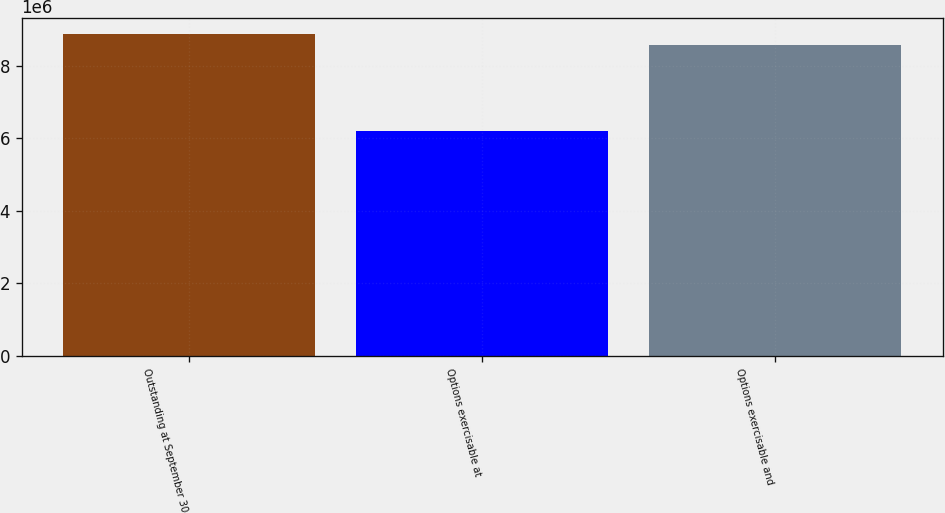<chart> <loc_0><loc_0><loc_500><loc_500><bar_chart><fcel>Outstanding at September 30<fcel>Options exercisable at<fcel>Options exercisable and<nl><fcel>8.87648e+06<fcel>6.20459e+06<fcel>8.58258e+06<nl></chart> 